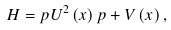Convert formula to latex. <formula><loc_0><loc_0><loc_500><loc_500>H = p U ^ { 2 } \left ( x \right ) p + V \left ( x \right ) ,</formula> 